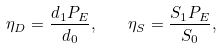Convert formula to latex. <formula><loc_0><loc_0><loc_500><loc_500>\eta _ { D } = \frac { d _ { 1 } P _ { E } } { d _ { 0 } } , \quad \eta _ { S } = \frac { S _ { 1 } P _ { E } } { S _ { 0 } } ,</formula> 